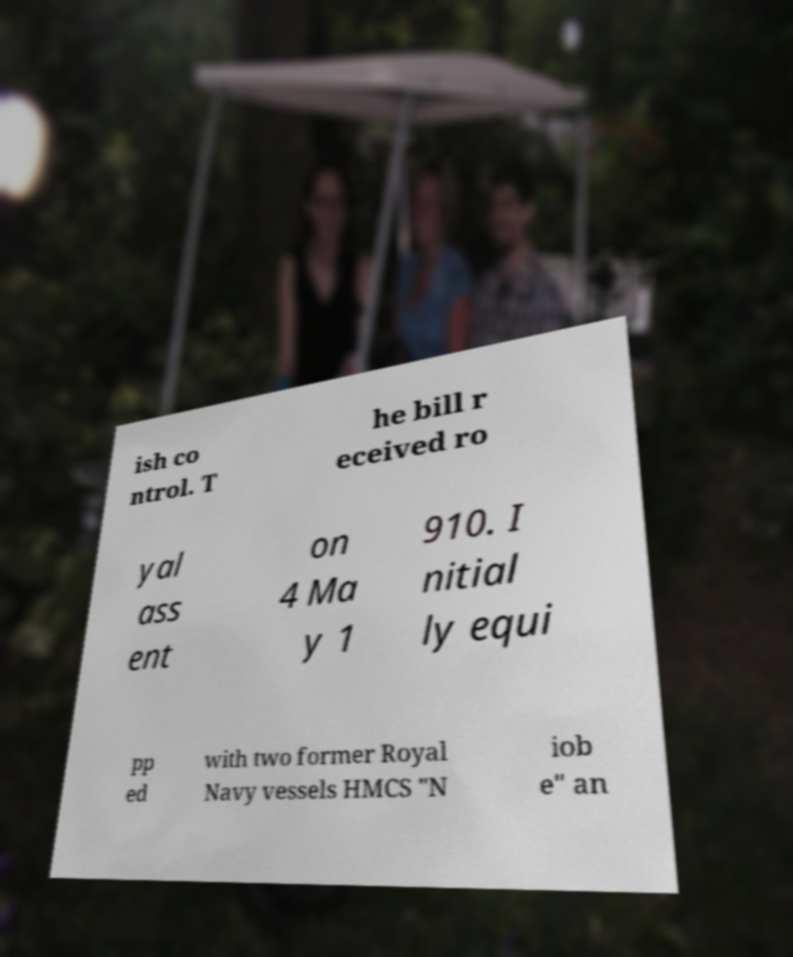Can you read and provide the text displayed in the image?This photo seems to have some interesting text. Can you extract and type it out for me? ish co ntrol. T he bill r eceived ro yal ass ent on 4 Ma y 1 910. I nitial ly equi pp ed with two former Royal Navy vessels HMCS "N iob e" an 